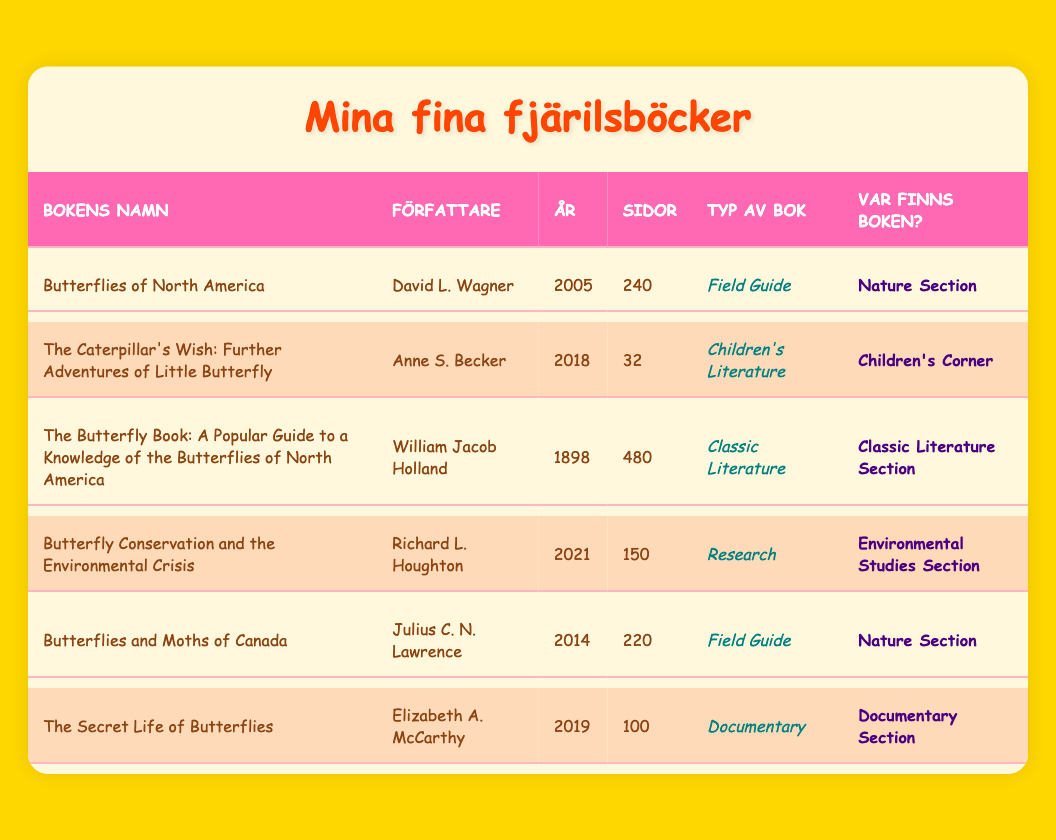What is the title of the book written by David L. Wagner? The relevant row shows that the book authored by David L. Wagner is titled "Butterflies of North America."
Answer: Butterflies of North America How many pages does "Butterfly Conservation and the Environmental Crisis" have? In the row for "Butterfly Conservation and the Environmental Crisis," it lists 150 pages.
Answer: 150 pages Are there two or more books listed in the genre of Field Guide? The table shows that there are two books categorized as Field Guide: "Butterflies of North America" and "Butterflies and Moths of Canada." Therefore, this statement is true.
Answer: Yes What is the publication year of the oldest book in the list? The oldest publication year in the table is 1898 for "The Butterfly Book: A Popular Guide to a Knowledge of the Butterflies of North America."
Answer: 1898 Which book has the most pages, and how many are there? Upon inspecting the pages column, "The Butterfly Book: A Popular Guide to a Knowledge of the Butterflies of North America" has the highest page count at 480 pages.
Answer: The Butterfly Book: A Popular Guide to a Knowledge of the Butterflies of North America, 480 pages How many books were published after 2015? The books published after 2015 are "The Caterpillar's Wish: Further Adventures of Little Butterfly" (2018), "Butterflies and Moths of Canada" (2014), and "The Secret Life of Butterflies" (2019). Counting these, we find two books published: one in 2018 and one in 2019.
Answer: 2 